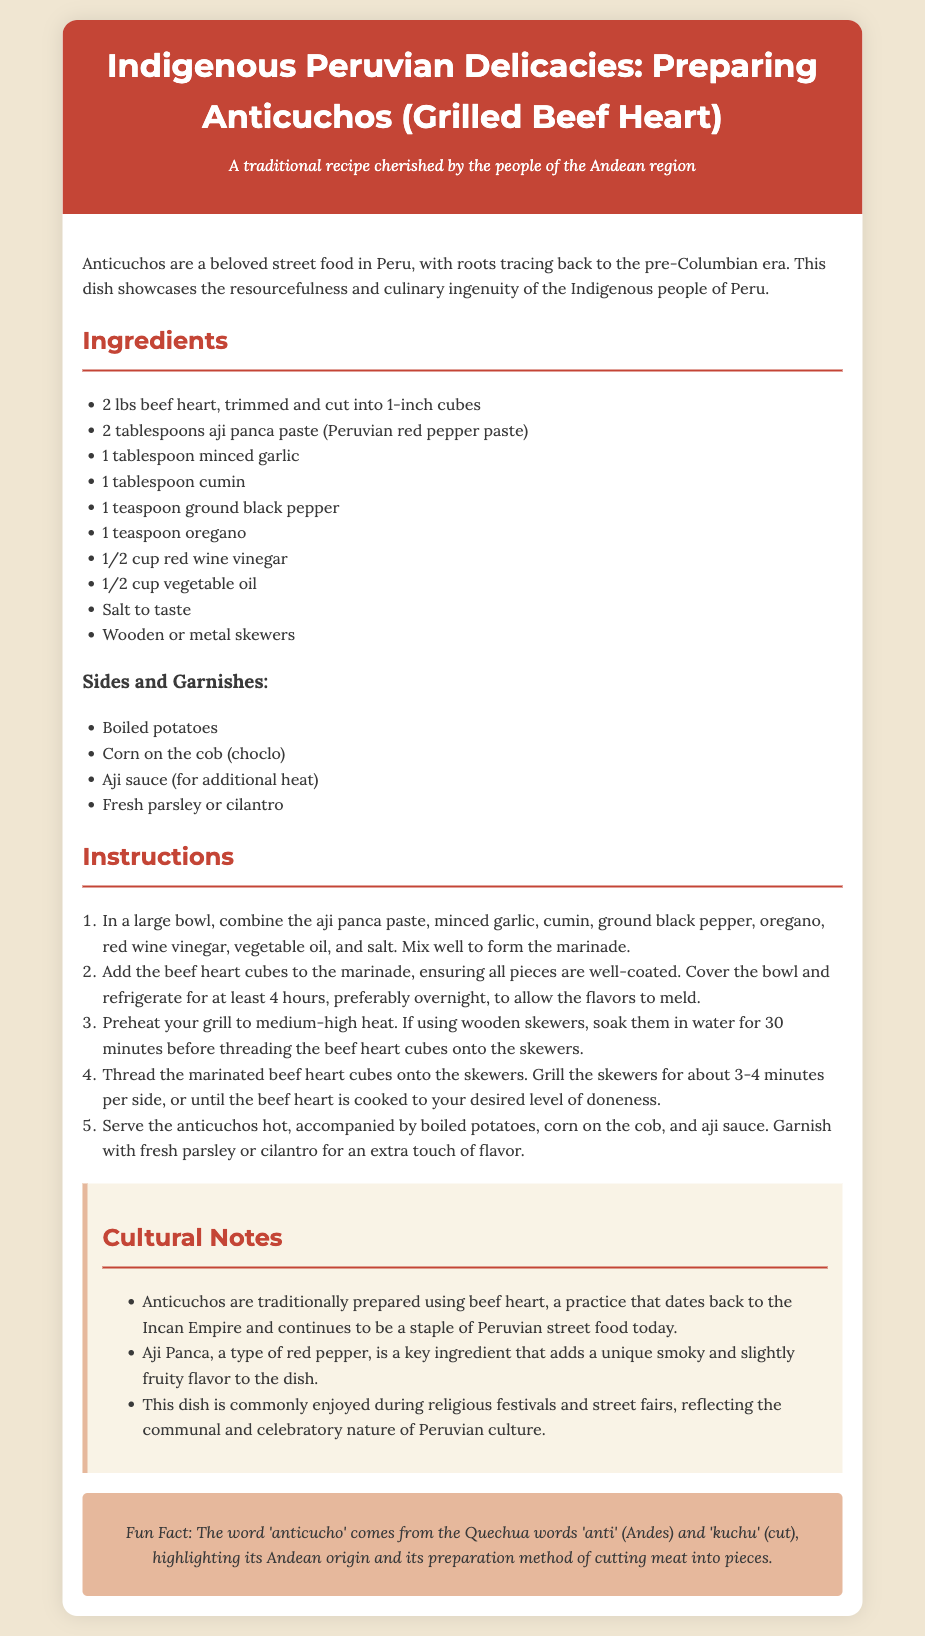what is the main ingredient in anticuchos? The main ingredient in anticuchos according to the recipe card is beef heart.
Answer: beef heart how many pounds of beef heart are needed? The recipe specifies that 2 pounds of beef heart are needed for the preparation.
Answer: 2 lbs what type of paste is used in the marinade? According to the ingredients list, aji panca paste is used in the marinade.
Answer: aji panca paste how long should the beef heart be marinated? The instructions recommend marinating the beef heart for at least 4 hours, preferably overnight.
Answer: at least 4 hours what is the cultural significance of anticuchos? The cultural notes mention that anticuchos are commonly enjoyed during religious festivals and street fairs in Peru.
Answer: religious festivals and street fairs what type of pepper is aji panca? Aji panca is described as a type of red pepper that adds a unique smoky and slightly fruity flavor to the dish.
Answer: red pepper how are the skewers grilled? The instructions state that the skewers should be grilled for about 3-4 minutes per side.
Answer: 3-4 minutes per side what garnishes are suggested for the dish? The recipe suggests using fresh parsley or cilantro as a garnish for the anticuchos.
Answer: fresh parsley or cilantro 